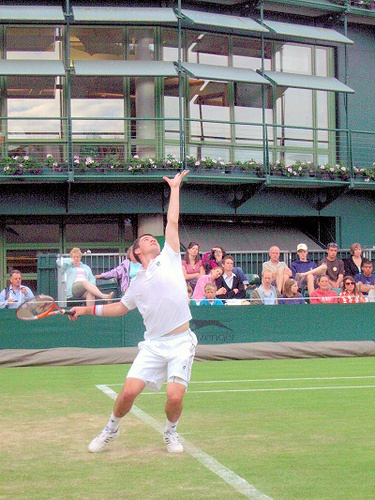Describe the objects in this image and their specific colors. I can see people in black, lavender, lightpink, darkgray, and tan tones, people in black, lavender, pink, lightpink, and gray tones, people in black, lightgray, lightpink, darkgray, and lightblue tones, tennis racket in black, darkgray, tan, and gray tones, and people in black, lightpink, purple, white, and brown tones in this image. 